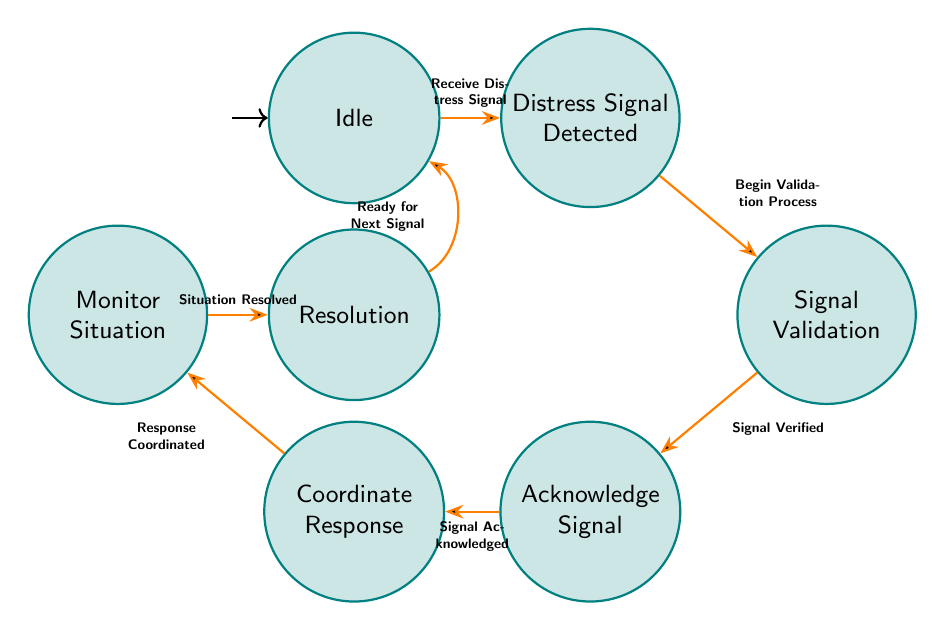What is the initial state of the Finite State Machine? According to the diagram, the initial state is marked, and the state labeled "Idle" is the first state. Therefore, it indicates that the machine starts waiting for incoming signals in the "Idle" state.
Answer: Idle How many states are present in the diagram? To determine this, we count the states listed in the diagram. There are a total of seven states: Idle, Distress Signal Detected, Signal Validation, Acknowledge Signal, Coordinate Response, Monitor Situation, and Resolution.
Answer: 7 What is the trigger to transition from "Monitor Situation" to "Resolution"? The transition from "Monitor Situation" to "Resolution" is based on the trigger labeled "Situation Resolved." When this trigger occurs, the Finite State Machine progresses to the "Resolution" state.
Answer: Situation Resolved What is the last state before returning to "Idle"? The last state that leads back to "Idle" is "Resolution." From there, the transition occurs when the trigger "Ready for Next Signal" is activated, bringing the machine back to the initial state.
Answer: Resolution What triggers the transition from "Acknowledge Signal" to "Coordinate Response"? The transition between these two states happens when the trigger "Signal Acknowledged" occurs. This indicates that the signal has been successfully acknowledged before the response coordination begins.
Answer: Signal Acknowledged What is the sequence of states when a distress signal is received? The sequence begins at "Idle," transitions to "Distress Signal Detected," then to "Signal Validation," progresses to "Acknowledge Signal," continues to "Coordinate Response," and finally moves to "Monitor Situation." This flow illustrates the process of handling the distress signal until the situation is monitored.
Answer: Idle → Distress Signal Detected → Signal Validation → Acknowledge Signal → Coordinate Response → Monitor Situation Which state is reached after the "Coordination Response" is processed? After processing the "Coordinate Response," the state reached is "Monitor Situation." This follows directly as per the transition determined by the trigger "Response Coordinated."
Answer: Monitor Situation What does the system do after the "Resolution" state? After reaching the "Resolution" state, the system transitions back to "Idle" once it receives the trigger "Ready for Next Signal." This indicates that the system is prepared to handle the next distress signal after concluding the current situation.
Answer: Idle 